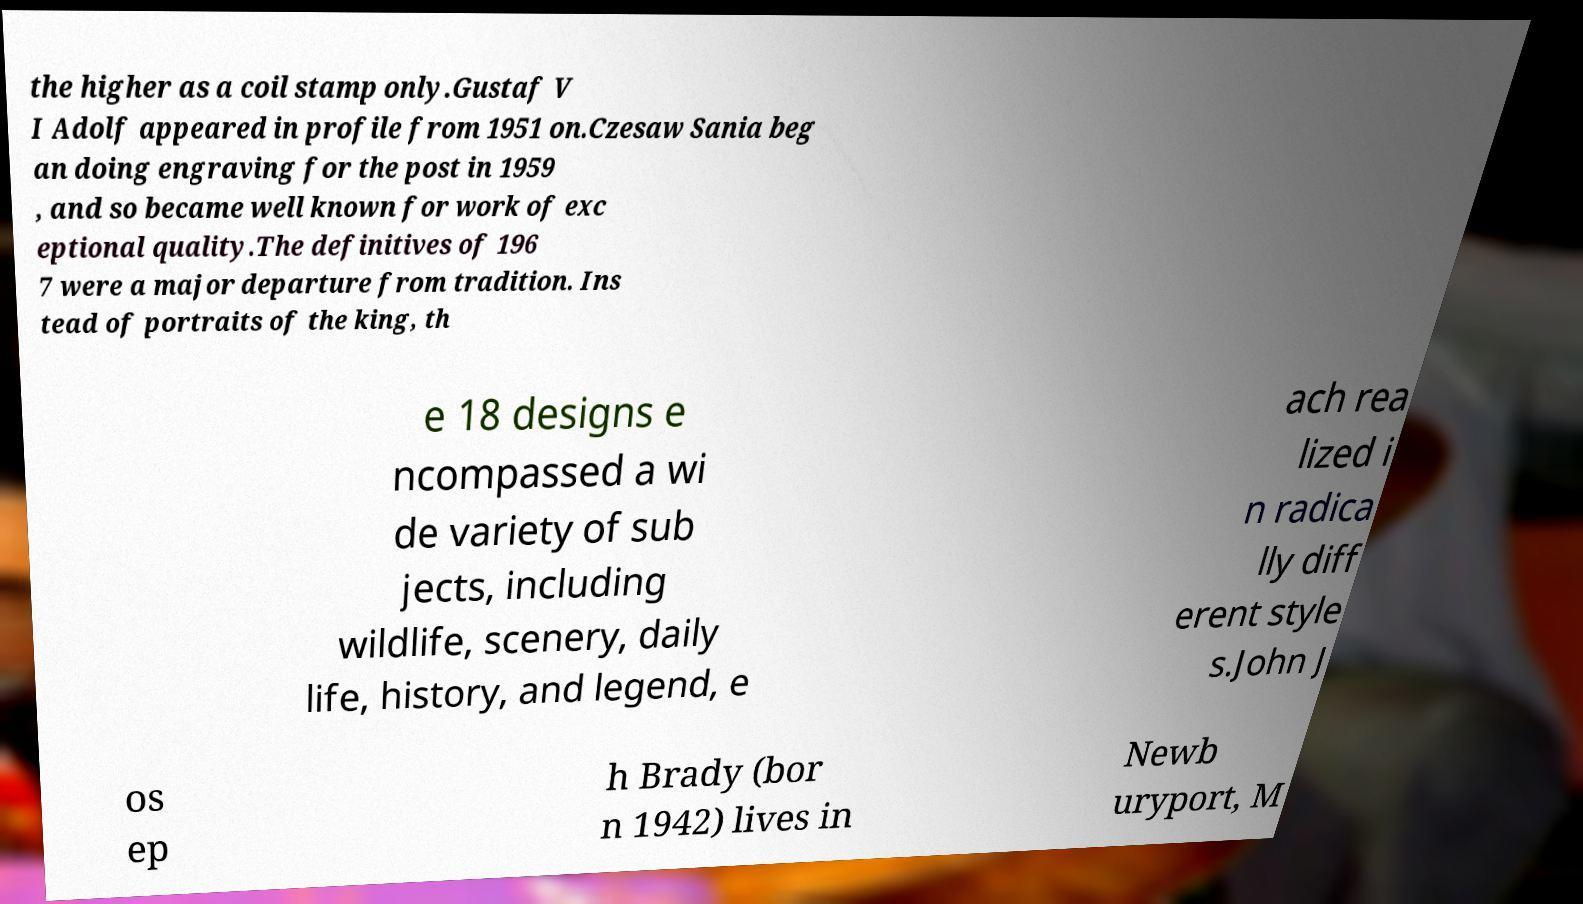Can you read and provide the text displayed in the image?This photo seems to have some interesting text. Can you extract and type it out for me? the higher as a coil stamp only.Gustaf V I Adolf appeared in profile from 1951 on.Czesaw Sania beg an doing engraving for the post in 1959 , and so became well known for work of exc eptional quality.The definitives of 196 7 were a major departure from tradition. Ins tead of portraits of the king, th e 18 designs e ncompassed a wi de variety of sub jects, including wildlife, scenery, daily life, history, and legend, e ach rea lized i n radica lly diff erent style s.John J os ep h Brady (bor n 1942) lives in Newb uryport, M 